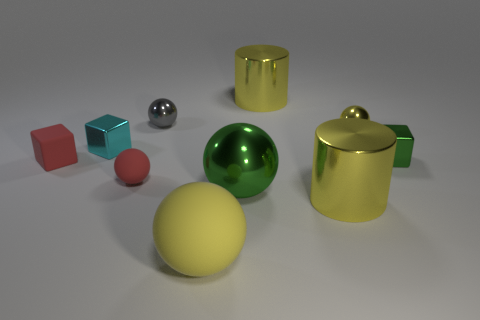Subtract all gray spheres. How many spheres are left? 4 Subtract all green metal balls. How many balls are left? 4 Subtract all purple spheres. Subtract all brown cylinders. How many spheres are left? 5 Subtract all blocks. How many objects are left? 7 Subtract 0 blue balls. How many objects are left? 10 Subtract all large metal cylinders. Subtract all tiny green shiny things. How many objects are left? 7 Add 4 yellow things. How many yellow things are left? 8 Add 2 cyan rubber cylinders. How many cyan rubber cylinders exist? 2 